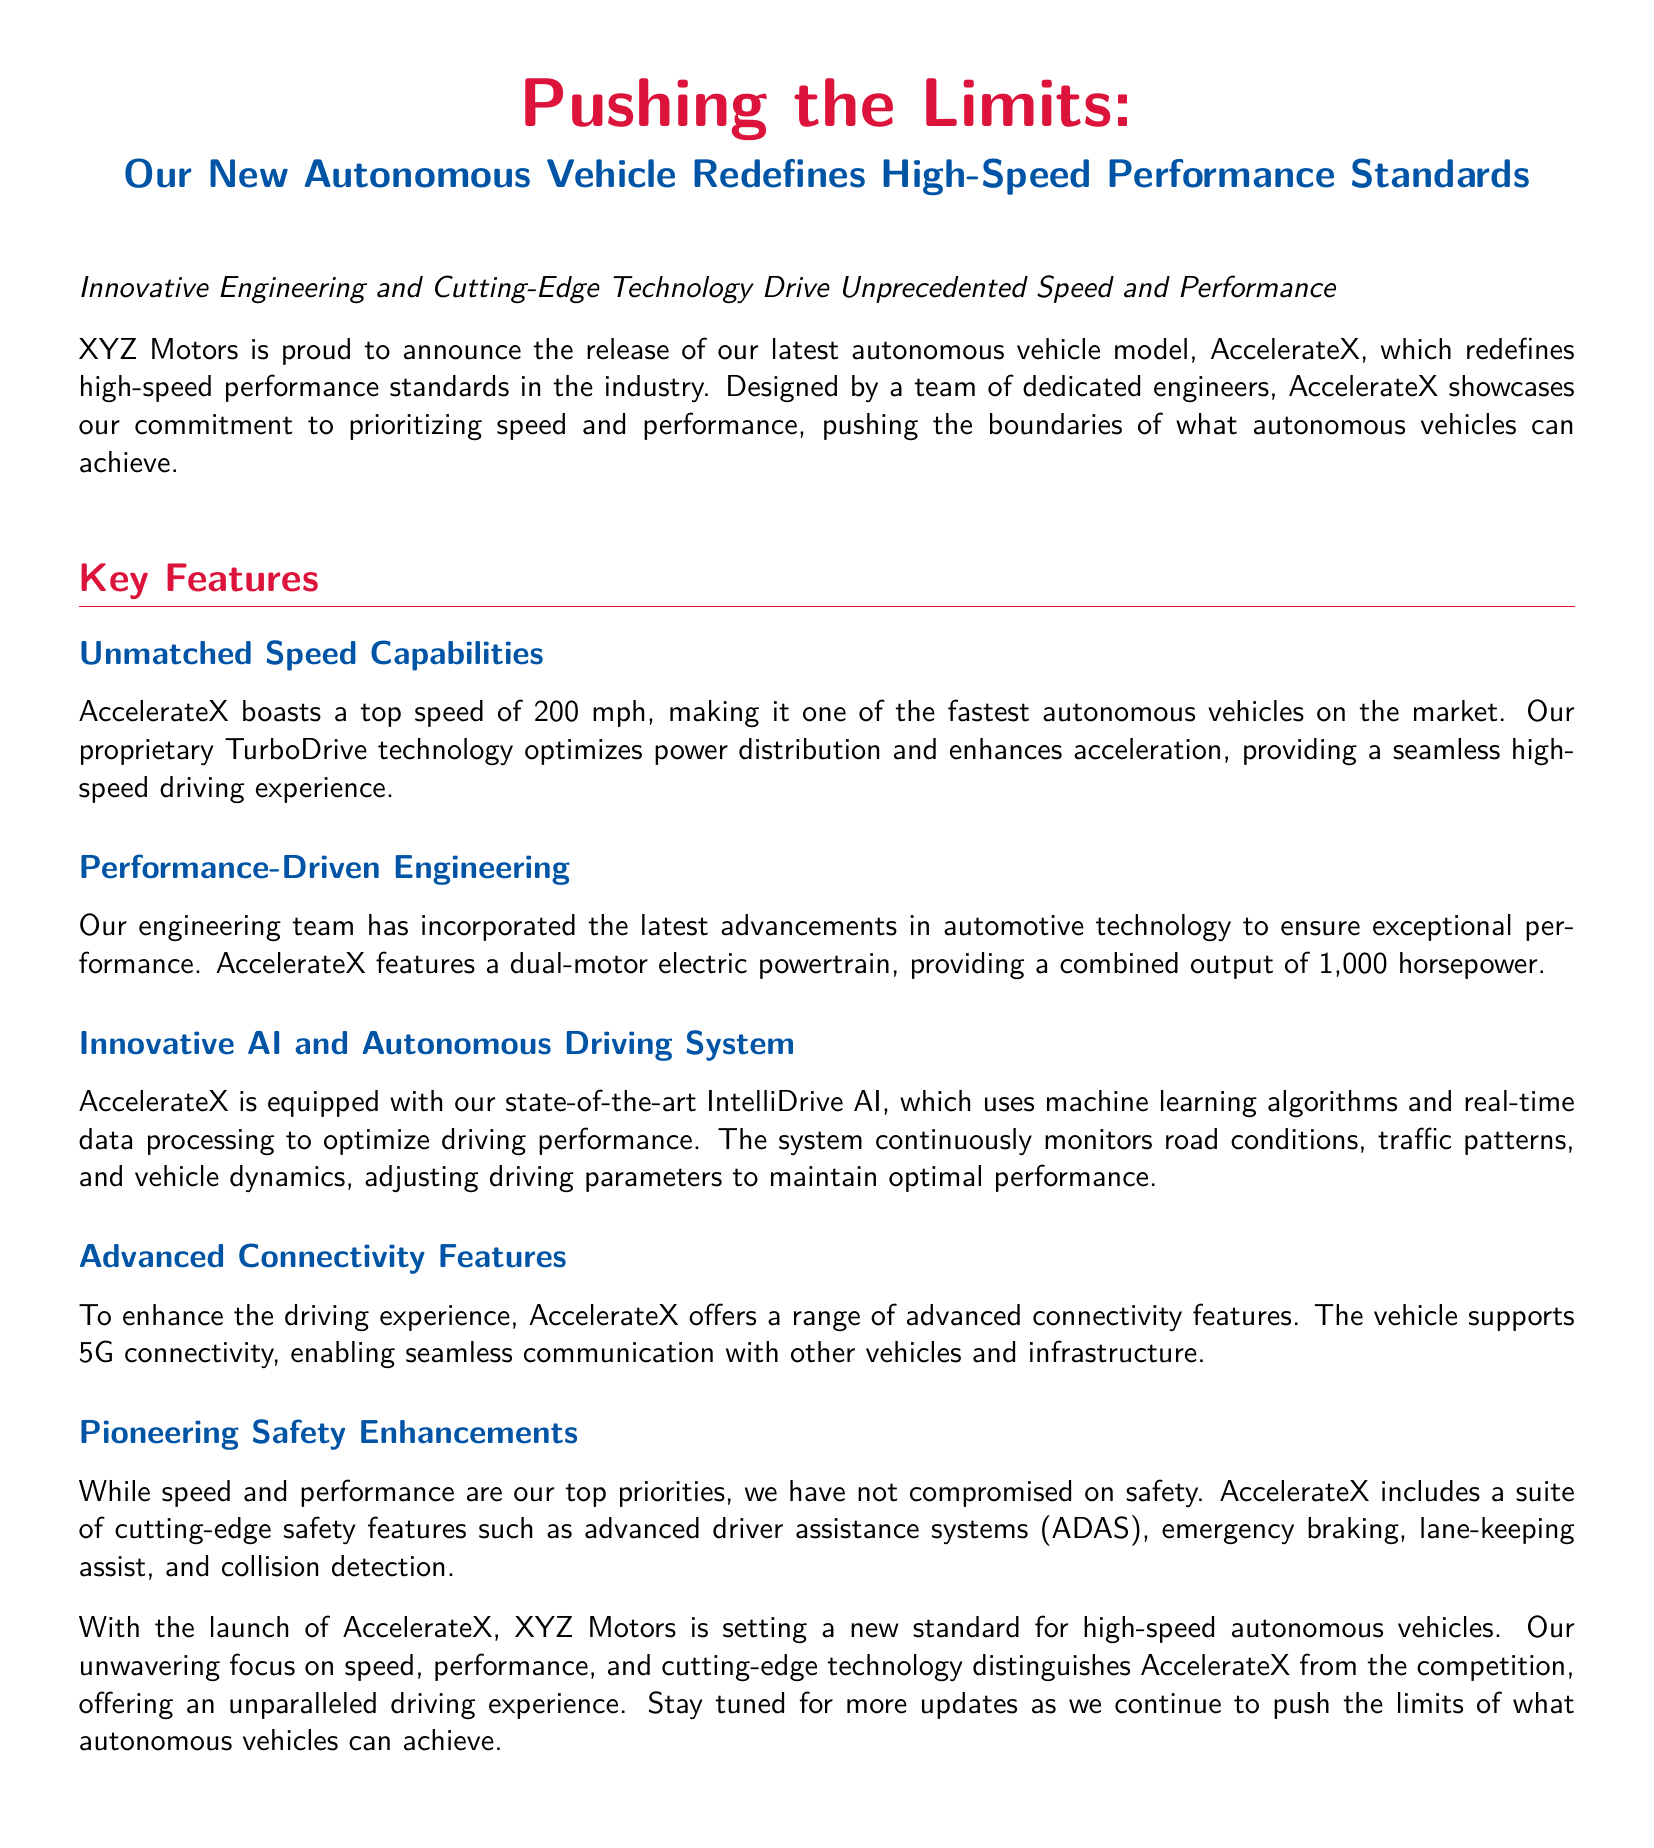What is the name of the new autonomous vehicle? The document states the name of the vehicle is AccelerateX.
Answer: AccelerateX What is the top speed of AccelerateX? The document mentions that AccelerateX has a top speed of 200 mph.
Answer: 200 mph How much horsepower does the dual-motor electric powertrain provide? The document indicates a combined output of 1,000 horsepower from the powertrain.
Answer: 1,000 horsepower What technology optimizes power distribution in AccelerateX? The document refers to TurboDrive technology as optimizing power distribution.
Answer: TurboDrive What is the main focus of XYZ Motors in developing AccelerateX? The document emphasizes the prioritization of speed and performance.
Answer: Speed and performance Which system adjusts driving parameters in real-time? The document describes the IntelliDrive AI as the system that adjusts driving parameters.
Answer: IntelliDrive AI What advanced feature enables communication with other vehicles? The document highlights 5G connectivity as the feature for communication.
Answer: 5G connectivity What safety features are included in AccelerateX? The document lists advanced driver assistance systems (ADAS), emergency braking, lane-keeping assist, and collision detection as safety features.
Answer: Advanced driver assistance systems (ADAS) What distinguishes AccelerateX from its competition? The document states that an unwavering focus on speed, performance, and cutting-edge technology distinguishes AccelerateX.
Answer: Speed, performance, and cutting-edge technology 